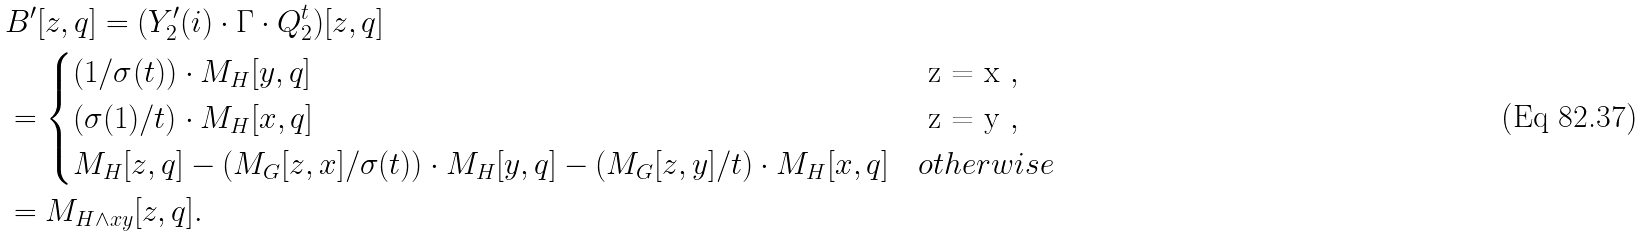<formula> <loc_0><loc_0><loc_500><loc_500>& B ^ { \prime } [ z , q ] = ( Y _ { 2 } ^ { \prime } ( i ) \cdot \Gamma \cdot Q _ { 2 } ^ { t } ) [ z , q ] \\ & = \begin{cases} ( 1 / \sigma ( t ) ) \cdot M _ { H } [ y , q ] & $ z = x $ , \\ ( \sigma ( 1 ) / t ) \cdot M _ { H } [ x , q ] & $ z = y $ , \\ M _ { H } [ z , q ] - ( M _ { G } [ z , x ] / \sigma ( t ) ) \cdot M _ { H } [ y , q ] - ( M _ { G } [ z , y ] / t ) \cdot M _ { H } [ x , q ] & o t h e r w i s e \end{cases} \\ & = M _ { H \wedge x y } [ z , q ] .</formula> 